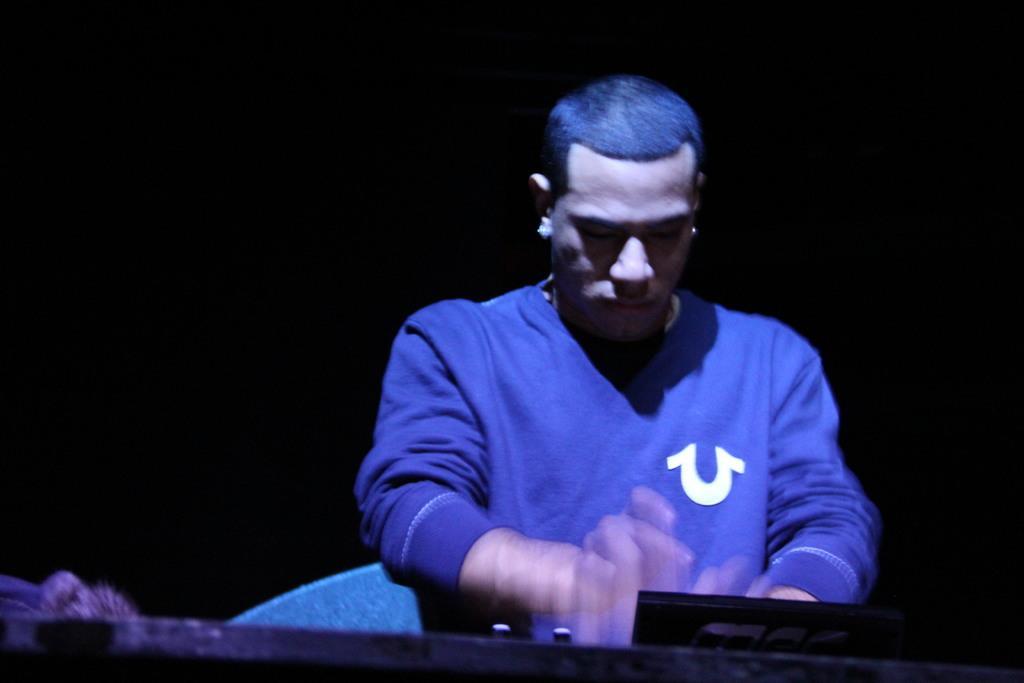Please provide a concise description of this image. In this image I can see a man and I can see he is wearing blue colour dress. In the front of him I can see a black colour thing and I can see this image is little bit in dark. 